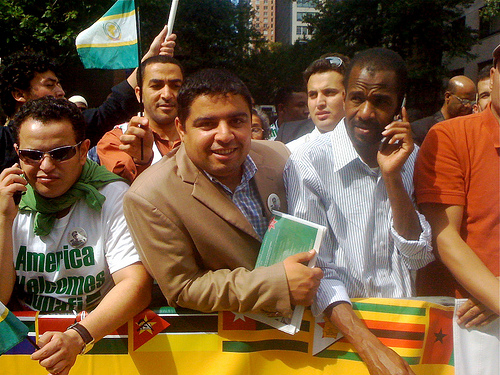What is the mood of the people in the image? The mood of the crowd in the image seems to be one of engagement and earnestness. The individual in a button-down shirt appears to be addressing the group or speaking into a phone, suggesting active communication or organization, while others seem to be looking around, possibly in anticipation of an event proceeding or in reaction to the surrounding atmosphere. 